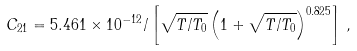Convert formula to latex. <formula><loc_0><loc_0><loc_500><loc_500>C _ { 2 1 } = 5 . 4 6 1 \times 1 0 ^ { - 1 2 } / \left [ \sqrt { T / T _ { 0 } } \left ( 1 + \sqrt { T / T _ { 0 } } \right ) ^ { 0 . 8 2 5 } \right ] \, ,</formula> 